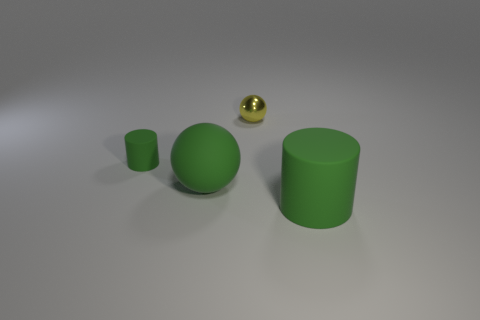Are there any other things that are the same material as the small yellow ball?
Your response must be concise. No. The large green rubber thing that is to the left of the green cylinder that is in front of the green cylinder to the left of the large green cylinder is what shape?
Offer a terse response. Sphere. Does the green object on the right side of the large matte ball have the same material as the sphere that is behind the large green matte ball?
Offer a terse response. No. There is a big green object that is made of the same material as the large cylinder; what shape is it?
Offer a very short reply. Sphere. Are there any other things of the same color as the big ball?
Provide a short and direct response. Yes. What number of big green matte objects are there?
Provide a succinct answer. 2. What is the large object that is left of the green cylinder right of the small cylinder made of?
Ensure brevity in your answer.  Rubber. What is the color of the cylinder that is behind the cylinder that is in front of the cylinder to the left of the large green cylinder?
Offer a very short reply. Green. Is the color of the small rubber cylinder the same as the rubber ball?
Provide a succinct answer. Yes. What number of red rubber cylinders are the same size as the yellow metallic thing?
Offer a terse response. 0. 